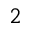<formula> <loc_0><loc_0><loc_500><loc_500>^ { 2 }</formula> 